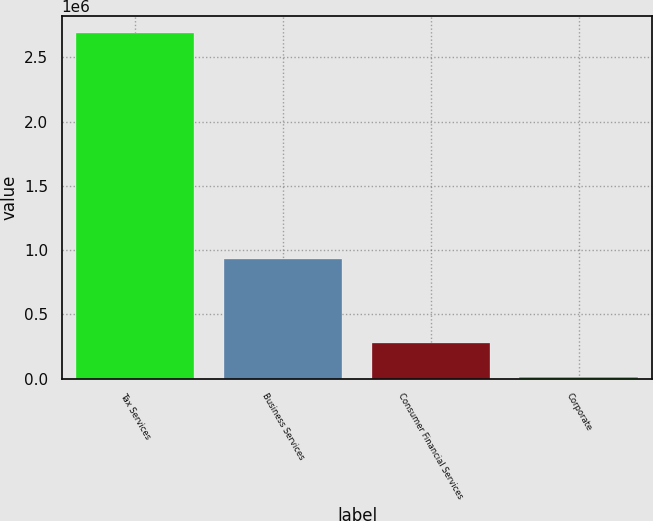Convert chart to OTSL. <chart><loc_0><loc_0><loc_500><loc_500><bar_chart><fcel>Tax Services<fcel>Business Services<fcel>Consumer Financial Services<fcel>Corporate<nl><fcel>2.68586e+06<fcel>932361<fcel>282054<fcel>14965<nl></chart> 